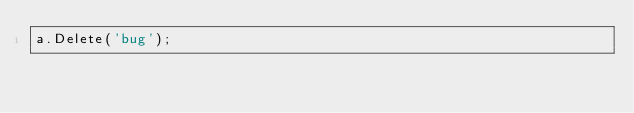Convert code to text. <code><loc_0><loc_0><loc_500><loc_500><_Pascal_>a.Delete('bug');</code> 